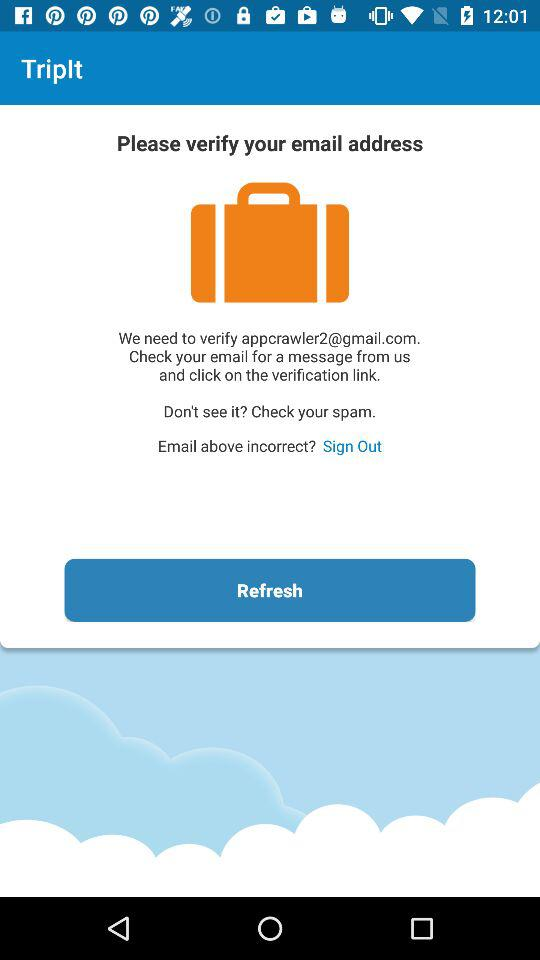What is the email address? The email address is appcrawler2@gmail.com. 